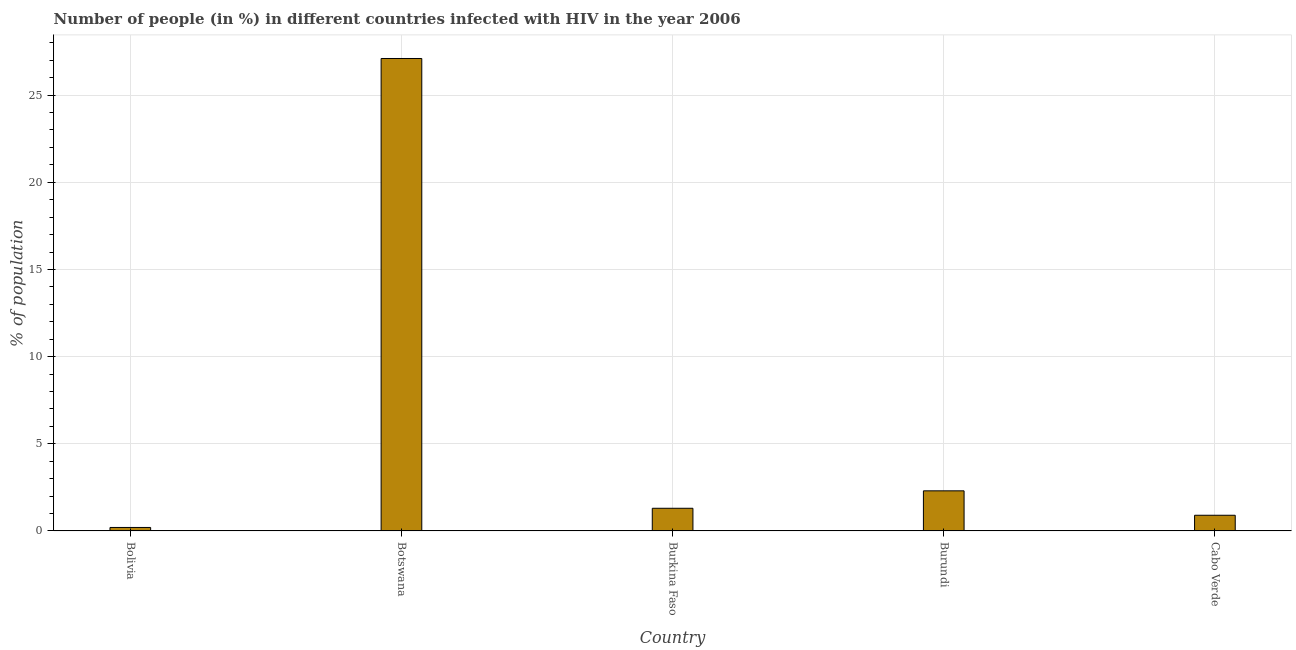Does the graph contain grids?
Provide a short and direct response. Yes. What is the title of the graph?
Provide a succinct answer. Number of people (in %) in different countries infected with HIV in the year 2006. What is the label or title of the X-axis?
Your answer should be compact. Country. What is the label or title of the Y-axis?
Keep it short and to the point. % of population. Across all countries, what is the maximum number of people infected with hiv?
Your answer should be compact. 27.1. Across all countries, what is the minimum number of people infected with hiv?
Provide a succinct answer. 0.2. In which country was the number of people infected with hiv maximum?
Your response must be concise. Botswana. In which country was the number of people infected with hiv minimum?
Provide a succinct answer. Bolivia. What is the sum of the number of people infected with hiv?
Give a very brief answer. 31.8. What is the difference between the number of people infected with hiv in Botswana and Burundi?
Give a very brief answer. 24.8. What is the average number of people infected with hiv per country?
Offer a terse response. 6.36. What is the median number of people infected with hiv?
Provide a succinct answer. 1.3. In how many countries, is the number of people infected with hiv greater than 20 %?
Make the answer very short. 1. What is the ratio of the number of people infected with hiv in Botswana to that in Cabo Verde?
Ensure brevity in your answer.  30.11. Is the number of people infected with hiv in Botswana less than that in Burundi?
Keep it short and to the point. No. What is the difference between the highest and the second highest number of people infected with hiv?
Ensure brevity in your answer.  24.8. Is the sum of the number of people infected with hiv in Bolivia and Botswana greater than the maximum number of people infected with hiv across all countries?
Offer a terse response. Yes. What is the difference between the highest and the lowest number of people infected with hiv?
Your response must be concise. 26.9. How many bars are there?
Offer a terse response. 5. How many countries are there in the graph?
Offer a terse response. 5. Are the values on the major ticks of Y-axis written in scientific E-notation?
Your answer should be very brief. No. What is the % of population in Bolivia?
Your response must be concise. 0.2. What is the % of population in Botswana?
Offer a very short reply. 27.1. What is the % of population in Burundi?
Your answer should be compact. 2.3. What is the difference between the % of population in Bolivia and Botswana?
Provide a short and direct response. -26.9. What is the difference between the % of population in Bolivia and Burkina Faso?
Ensure brevity in your answer.  -1.1. What is the difference between the % of population in Bolivia and Cabo Verde?
Your answer should be very brief. -0.7. What is the difference between the % of population in Botswana and Burkina Faso?
Your answer should be compact. 25.8. What is the difference between the % of population in Botswana and Burundi?
Your answer should be very brief. 24.8. What is the difference between the % of population in Botswana and Cabo Verde?
Ensure brevity in your answer.  26.2. What is the difference between the % of population in Burkina Faso and Burundi?
Keep it short and to the point. -1. What is the difference between the % of population in Burkina Faso and Cabo Verde?
Keep it short and to the point. 0.4. What is the ratio of the % of population in Bolivia to that in Botswana?
Provide a short and direct response. 0.01. What is the ratio of the % of population in Bolivia to that in Burkina Faso?
Ensure brevity in your answer.  0.15. What is the ratio of the % of population in Bolivia to that in Burundi?
Keep it short and to the point. 0.09. What is the ratio of the % of population in Bolivia to that in Cabo Verde?
Ensure brevity in your answer.  0.22. What is the ratio of the % of population in Botswana to that in Burkina Faso?
Make the answer very short. 20.85. What is the ratio of the % of population in Botswana to that in Burundi?
Provide a succinct answer. 11.78. What is the ratio of the % of population in Botswana to that in Cabo Verde?
Your answer should be very brief. 30.11. What is the ratio of the % of population in Burkina Faso to that in Burundi?
Offer a terse response. 0.56. What is the ratio of the % of population in Burkina Faso to that in Cabo Verde?
Your answer should be very brief. 1.44. What is the ratio of the % of population in Burundi to that in Cabo Verde?
Offer a very short reply. 2.56. 